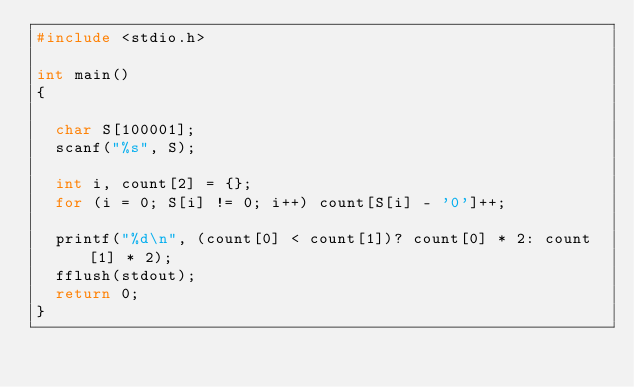Convert code to text. <code><loc_0><loc_0><loc_500><loc_500><_C_>#include <stdio.h>

int main()
{
	
	char S[100001];
	scanf("%s", S);

	int i, count[2] = {};
	for (i = 0; S[i] != 0; i++) count[S[i] - '0']++;
	
	printf("%d\n", (count[0] < count[1])? count[0] * 2: count[1] * 2);
	fflush(stdout);
	return 0;
}</code> 